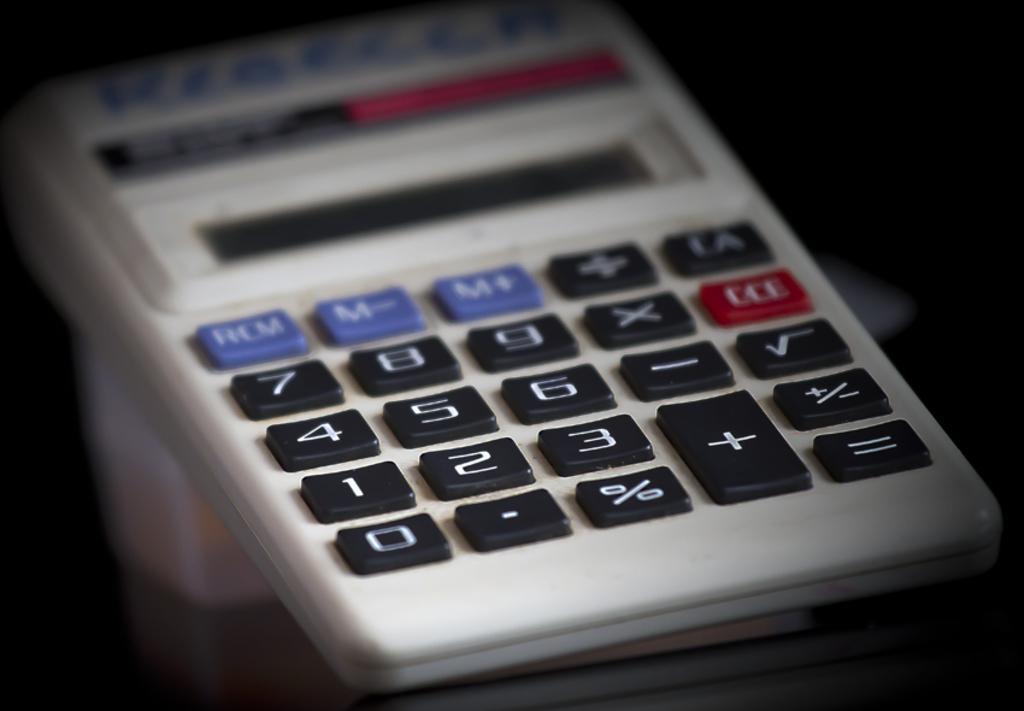In one or two sentences, can you explain what this image depicts? In this picture there is a calculator. There is text and there are numbers and symbols on the buttons on the calculator. At the bottom it looks like a table and there is a reflection of a calculator on the table. At the back there is a black background. 